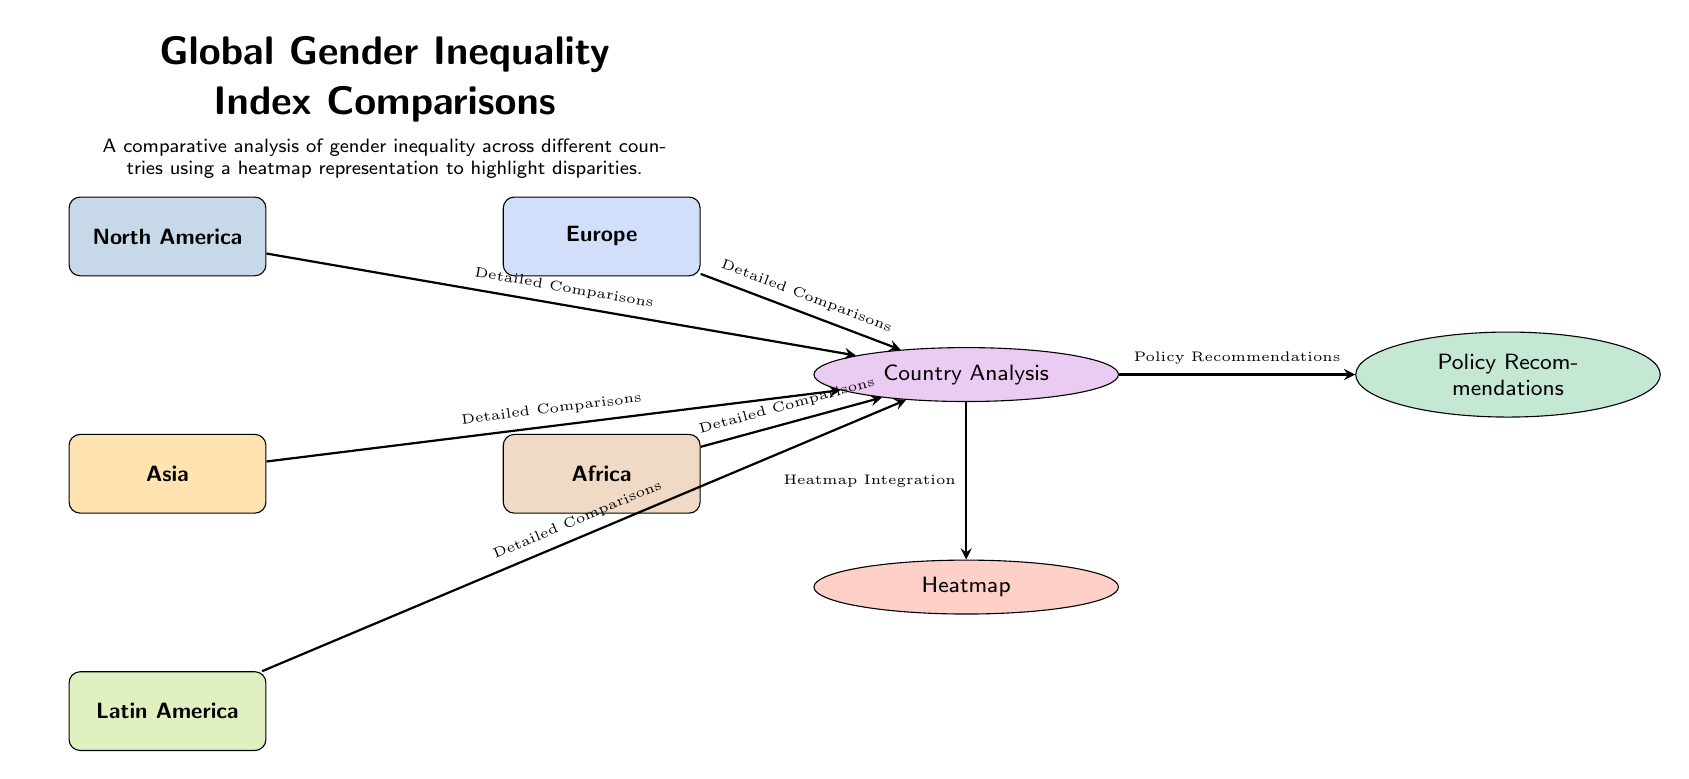What are the regions represented in the diagram? The diagram includes five regions: North America, Europe, Asia, Africa, and Latin America. Each region is visually distinct and labeled accordingly.
Answer: North America, Europe, Asia, Africa, Latin America How many analysis components are there in the diagram? There are three analysis components: Country Analysis, Heatmap, and Policy Recommendations. Each is represented by an ellipse and linked to the regional nodes.
Answer: 3 Which analysis component is connected to heatmap integration? The connection to heatmap integration is from the Country Analysis component. An arrow indicates the flow of information from Country Analysis to Heatmap.
Answer: Country Analysis Which region has the least prominence in the color scheme? Latin America is represented by a lighter shade of green compared to the others, indicating relatively lower prominence in the context of the Global Gender Inequality Index.
Answer: Latin America What is the main title of the diagram? The title at the top of the diagram is "Global Gender Inequality Index Comparisons," summarizing the purpose of the graphic.
Answer: Global Gender Inequality Index Comparisons Which component is positioned directly below the Country Analysis node? The Heatmap component is directly below the Country Analysis, indicating its subordinate role in the diagram's structure.
Answer: Heatmap What does the description at the top convey about the analysis? The description outlines that the diagram provides a comparative analysis of gender inequality across different countries, emphasizing disparities through a heatmap representation.
Answer: Comparative analysis of gender inequality What type of arrows connect the regional nodes to the Country Analysis? The arrows connecting the regional nodes to the Country Analysis component are labeled as "Detailed Comparisons," indicating the nature of the information flow.
Answer: Detailed Comparisons Which component is situated to the right of Country Analysis? The Policy Recommendations component is placed to the right of Country Analysis, suggesting a follow-up or proposed actions based on the analysis.
Answer: Policy Recommendations 